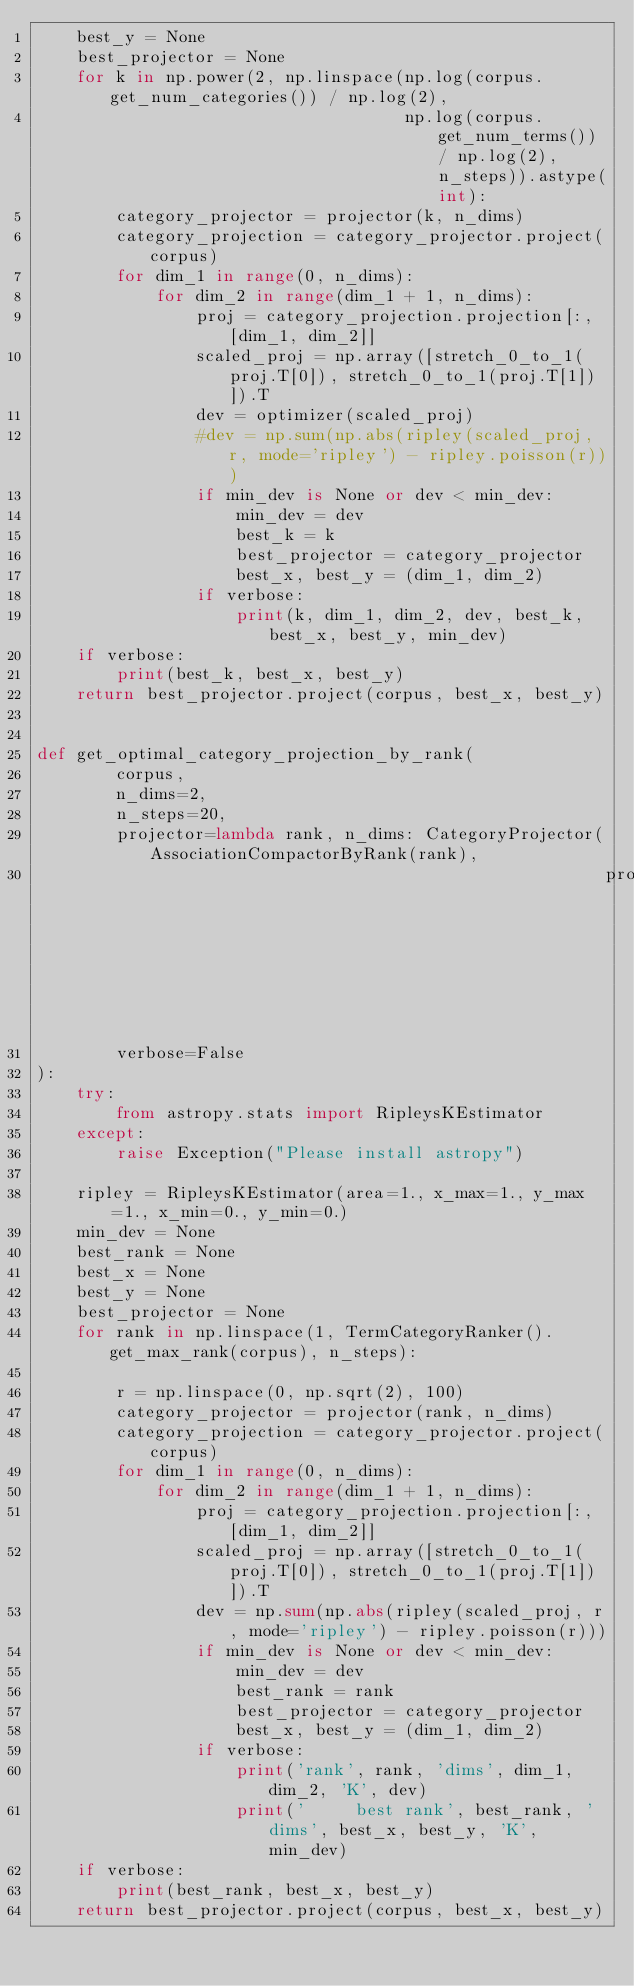Convert code to text. <code><loc_0><loc_0><loc_500><loc_500><_Python_>    best_y = None
    best_projector = None
    for k in np.power(2, np.linspace(np.log(corpus.get_num_categories()) / np.log(2),
                                     np.log(corpus.get_num_terms()) / np.log(2), n_steps)).astype(int):
        category_projector = projector(k, n_dims)
        category_projection = category_projector.project(corpus)
        for dim_1 in range(0, n_dims):
            for dim_2 in range(dim_1 + 1, n_dims):
                proj = category_projection.projection[:, [dim_1, dim_2]]
                scaled_proj = np.array([stretch_0_to_1(proj.T[0]), stretch_0_to_1(proj.T[1])]).T
                dev = optimizer(scaled_proj)
                #dev = np.sum(np.abs(ripley(scaled_proj, r, mode='ripley') - ripley.poisson(r)))
                if min_dev is None or dev < min_dev:
                    min_dev = dev
                    best_k = k
                    best_projector = category_projector
                    best_x, best_y = (dim_1, dim_2)
                if verbose:
                    print(k, dim_1, dim_2, dev, best_k, best_x, best_y, min_dev)
    if verbose:
        print(best_k, best_x, best_y)
    return best_projector.project(corpus, best_x, best_y)


def get_optimal_category_projection_by_rank(
        corpus,
        n_dims=2,
        n_steps=20,
        projector=lambda rank, n_dims: CategoryProjector(AssociationCompactorByRank(rank),
                                                         projector=PCA(n_dims)),
        verbose=False
):
    try:
        from astropy.stats import RipleysKEstimator
    except:
        raise Exception("Please install astropy")

    ripley = RipleysKEstimator(area=1., x_max=1., y_max=1., x_min=0., y_min=0.)
    min_dev = None
    best_rank = None
    best_x = None
    best_y = None
    best_projector = None
    for rank in np.linspace(1, TermCategoryRanker().get_max_rank(corpus), n_steps):

        r = np.linspace(0, np.sqrt(2), 100)
        category_projector = projector(rank, n_dims)
        category_projection = category_projector.project(corpus)
        for dim_1 in range(0, n_dims):
            for dim_2 in range(dim_1 + 1, n_dims):
                proj = category_projection.projection[:, [dim_1, dim_2]]
                scaled_proj = np.array([stretch_0_to_1(proj.T[0]), stretch_0_to_1(proj.T[1])]).T
                dev = np.sum(np.abs(ripley(scaled_proj, r, mode='ripley') - ripley.poisson(r)))
                if min_dev is None or dev < min_dev:
                    min_dev = dev
                    best_rank = rank
                    best_projector = category_projector
                    best_x, best_y = (dim_1, dim_2)
                if verbose:
                    print('rank', rank, 'dims', dim_1, dim_2, 'K', dev)
                    print('     best rank', best_rank, 'dims', best_x, best_y, 'K', min_dev)
    if verbose:
        print(best_rank, best_x, best_y)
    return best_projector.project(corpus, best_x, best_y)
</code> 